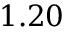<formula> <loc_0><loc_0><loc_500><loc_500>1 . 2 0</formula> 